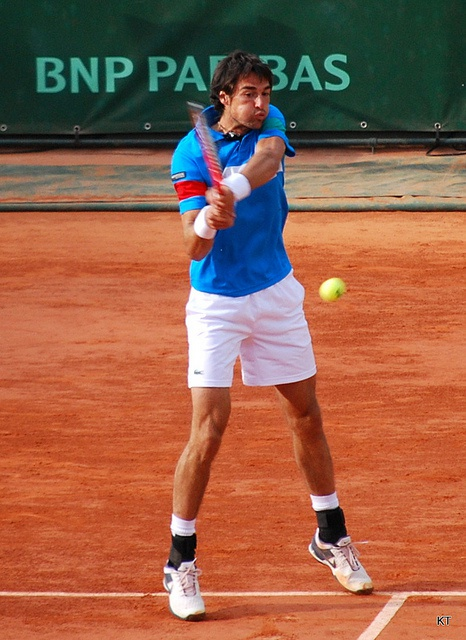Describe the objects in this image and their specific colors. I can see people in darkgreen, lavender, maroon, and black tones, tennis racket in darkgreen, gray, violet, and salmon tones, and sports ball in darkgreen, khaki, orange, and lightyellow tones in this image. 